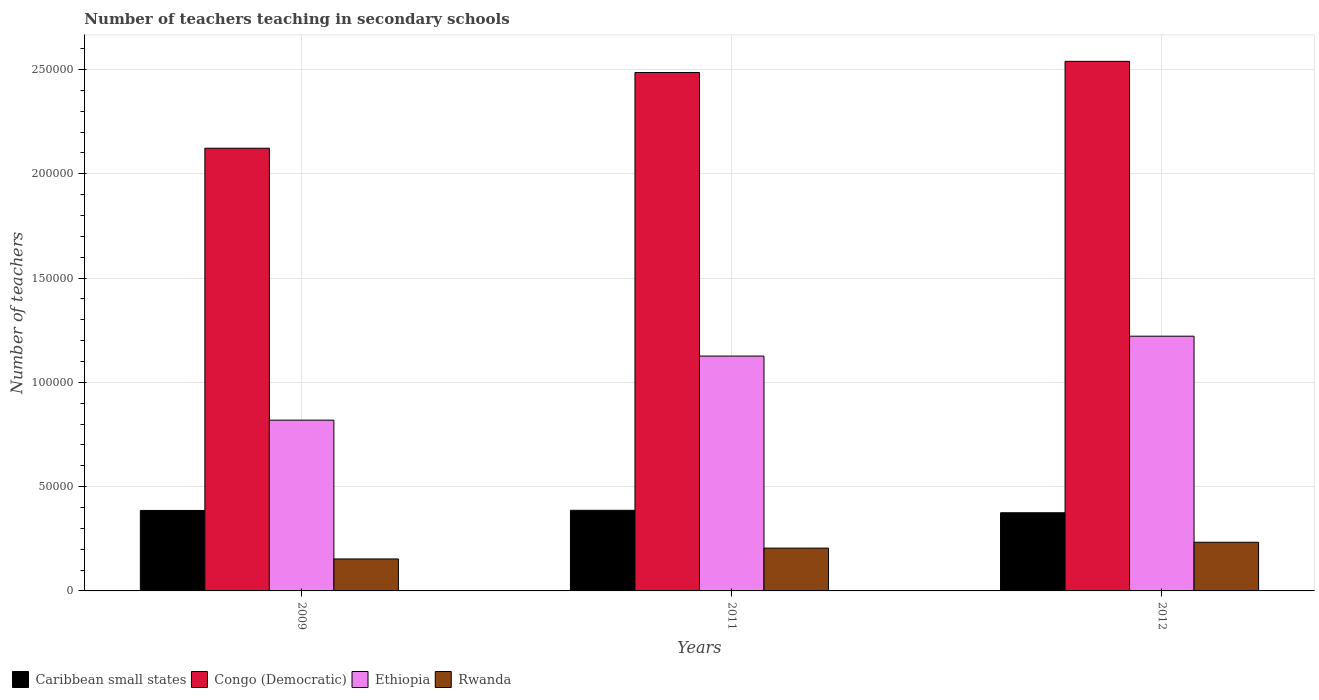How many different coloured bars are there?
Provide a succinct answer. 4. Are the number of bars per tick equal to the number of legend labels?
Make the answer very short. Yes. What is the number of teachers teaching in secondary schools in Ethiopia in 2012?
Provide a short and direct response. 1.22e+05. Across all years, what is the maximum number of teachers teaching in secondary schools in Ethiopia?
Provide a short and direct response. 1.22e+05. Across all years, what is the minimum number of teachers teaching in secondary schools in Ethiopia?
Make the answer very short. 8.19e+04. In which year was the number of teachers teaching in secondary schools in Caribbean small states minimum?
Offer a very short reply. 2012. What is the total number of teachers teaching in secondary schools in Rwanda in the graph?
Your response must be concise. 5.92e+04. What is the difference between the number of teachers teaching in secondary schools in Caribbean small states in 2011 and that in 2012?
Keep it short and to the point. 1172.01. What is the difference between the number of teachers teaching in secondary schools in Caribbean small states in 2009 and the number of teachers teaching in secondary schools in Congo (Democratic) in 2012?
Give a very brief answer. -2.15e+05. What is the average number of teachers teaching in secondary schools in Caribbean small states per year?
Offer a very short reply. 3.82e+04. In the year 2009, what is the difference between the number of teachers teaching in secondary schools in Congo (Democratic) and number of teachers teaching in secondary schools in Ethiopia?
Your answer should be very brief. 1.30e+05. What is the ratio of the number of teachers teaching in secondary schools in Rwanda in 2009 to that in 2011?
Give a very brief answer. 0.75. What is the difference between the highest and the second highest number of teachers teaching in secondary schools in Rwanda?
Give a very brief answer. 2813. What is the difference between the highest and the lowest number of teachers teaching in secondary schools in Rwanda?
Keep it short and to the point. 8006. In how many years, is the number of teachers teaching in secondary schools in Congo (Democratic) greater than the average number of teachers teaching in secondary schools in Congo (Democratic) taken over all years?
Keep it short and to the point. 2. Is the sum of the number of teachers teaching in secondary schools in Rwanda in 2009 and 2012 greater than the maximum number of teachers teaching in secondary schools in Caribbean small states across all years?
Give a very brief answer. Yes. What does the 3rd bar from the left in 2011 represents?
Offer a terse response. Ethiopia. What does the 3rd bar from the right in 2011 represents?
Provide a succinct answer. Congo (Democratic). Are all the bars in the graph horizontal?
Provide a succinct answer. No. What is the difference between two consecutive major ticks on the Y-axis?
Your answer should be very brief. 5.00e+04. Where does the legend appear in the graph?
Provide a succinct answer. Bottom left. What is the title of the graph?
Make the answer very short. Number of teachers teaching in secondary schools. What is the label or title of the Y-axis?
Your response must be concise. Number of teachers. What is the Number of teachers of Caribbean small states in 2009?
Make the answer very short. 3.86e+04. What is the Number of teachers of Congo (Democratic) in 2009?
Offer a terse response. 2.12e+05. What is the Number of teachers of Ethiopia in 2009?
Ensure brevity in your answer.  8.19e+04. What is the Number of teachers in Rwanda in 2009?
Provide a short and direct response. 1.53e+04. What is the Number of teachers in Caribbean small states in 2011?
Your answer should be very brief. 3.87e+04. What is the Number of teachers in Congo (Democratic) in 2011?
Your answer should be very brief. 2.49e+05. What is the Number of teachers in Ethiopia in 2011?
Your response must be concise. 1.13e+05. What is the Number of teachers of Rwanda in 2011?
Provide a succinct answer. 2.05e+04. What is the Number of teachers of Caribbean small states in 2012?
Provide a succinct answer. 3.75e+04. What is the Number of teachers of Congo (Democratic) in 2012?
Give a very brief answer. 2.54e+05. What is the Number of teachers in Ethiopia in 2012?
Offer a very short reply. 1.22e+05. What is the Number of teachers of Rwanda in 2012?
Offer a very short reply. 2.33e+04. Across all years, what is the maximum Number of teachers of Caribbean small states?
Ensure brevity in your answer.  3.87e+04. Across all years, what is the maximum Number of teachers in Congo (Democratic)?
Your answer should be compact. 2.54e+05. Across all years, what is the maximum Number of teachers of Ethiopia?
Provide a succinct answer. 1.22e+05. Across all years, what is the maximum Number of teachers of Rwanda?
Provide a succinct answer. 2.33e+04. Across all years, what is the minimum Number of teachers in Caribbean small states?
Your answer should be very brief. 3.75e+04. Across all years, what is the minimum Number of teachers of Congo (Democratic)?
Provide a succinct answer. 2.12e+05. Across all years, what is the minimum Number of teachers in Ethiopia?
Offer a terse response. 8.19e+04. Across all years, what is the minimum Number of teachers in Rwanda?
Provide a short and direct response. 1.53e+04. What is the total Number of teachers of Caribbean small states in the graph?
Offer a very short reply. 1.15e+05. What is the total Number of teachers in Congo (Democratic) in the graph?
Make the answer very short. 7.15e+05. What is the total Number of teachers of Ethiopia in the graph?
Offer a very short reply. 3.17e+05. What is the total Number of teachers in Rwanda in the graph?
Provide a succinct answer. 5.92e+04. What is the difference between the Number of teachers of Caribbean small states in 2009 and that in 2011?
Offer a terse response. -65.87. What is the difference between the Number of teachers in Congo (Democratic) in 2009 and that in 2011?
Make the answer very short. -3.63e+04. What is the difference between the Number of teachers in Ethiopia in 2009 and that in 2011?
Your response must be concise. -3.07e+04. What is the difference between the Number of teachers of Rwanda in 2009 and that in 2011?
Your answer should be compact. -5193. What is the difference between the Number of teachers in Caribbean small states in 2009 and that in 2012?
Ensure brevity in your answer.  1106.14. What is the difference between the Number of teachers of Congo (Democratic) in 2009 and that in 2012?
Offer a very short reply. -4.17e+04. What is the difference between the Number of teachers in Ethiopia in 2009 and that in 2012?
Your response must be concise. -4.03e+04. What is the difference between the Number of teachers of Rwanda in 2009 and that in 2012?
Your response must be concise. -8006. What is the difference between the Number of teachers in Caribbean small states in 2011 and that in 2012?
Your response must be concise. 1172.01. What is the difference between the Number of teachers of Congo (Democratic) in 2011 and that in 2012?
Your answer should be very brief. -5338. What is the difference between the Number of teachers of Ethiopia in 2011 and that in 2012?
Your answer should be compact. -9539. What is the difference between the Number of teachers of Rwanda in 2011 and that in 2012?
Ensure brevity in your answer.  -2813. What is the difference between the Number of teachers of Caribbean small states in 2009 and the Number of teachers of Congo (Democratic) in 2011?
Your answer should be very brief. -2.10e+05. What is the difference between the Number of teachers in Caribbean small states in 2009 and the Number of teachers in Ethiopia in 2011?
Offer a terse response. -7.40e+04. What is the difference between the Number of teachers in Caribbean small states in 2009 and the Number of teachers in Rwanda in 2011?
Provide a succinct answer. 1.81e+04. What is the difference between the Number of teachers of Congo (Democratic) in 2009 and the Number of teachers of Ethiopia in 2011?
Offer a terse response. 9.97e+04. What is the difference between the Number of teachers of Congo (Democratic) in 2009 and the Number of teachers of Rwanda in 2011?
Give a very brief answer. 1.92e+05. What is the difference between the Number of teachers in Ethiopia in 2009 and the Number of teachers in Rwanda in 2011?
Make the answer very short. 6.14e+04. What is the difference between the Number of teachers in Caribbean small states in 2009 and the Number of teachers in Congo (Democratic) in 2012?
Your response must be concise. -2.15e+05. What is the difference between the Number of teachers of Caribbean small states in 2009 and the Number of teachers of Ethiopia in 2012?
Offer a terse response. -8.36e+04. What is the difference between the Number of teachers in Caribbean small states in 2009 and the Number of teachers in Rwanda in 2012?
Make the answer very short. 1.53e+04. What is the difference between the Number of teachers in Congo (Democratic) in 2009 and the Number of teachers in Ethiopia in 2012?
Offer a terse response. 9.01e+04. What is the difference between the Number of teachers of Congo (Democratic) in 2009 and the Number of teachers of Rwanda in 2012?
Your response must be concise. 1.89e+05. What is the difference between the Number of teachers in Ethiopia in 2009 and the Number of teachers in Rwanda in 2012?
Provide a succinct answer. 5.86e+04. What is the difference between the Number of teachers in Caribbean small states in 2011 and the Number of teachers in Congo (Democratic) in 2012?
Provide a short and direct response. -2.15e+05. What is the difference between the Number of teachers in Caribbean small states in 2011 and the Number of teachers in Ethiopia in 2012?
Give a very brief answer. -8.35e+04. What is the difference between the Number of teachers of Caribbean small states in 2011 and the Number of teachers of Rwanda in 2012?
Give a very brief answer. 1.53e+04. What is the difference between the Number of teachers in Congo (Democratic) in 2011 and the Number of teachers in Ethiopia in 2012?
Provide a succinct answer. 1.26e+05. What is the difference between the Number of teachers in Congo (Democratic) in 2011 and the Number of teachers in Rwanda in 2012?
Make the answer very short. 2.25e+05. What is the difference between the Number of teachers in Ethiopia in 2011 and the Number of teachers in Rwanda in 2012?
Keep it short and to the point. 8.93e+04. What is the average Number of teachers in Caribbean small states per year?
Offer a very short reply. 3.82e+04. What is the average Number of teachers in Congo (Democratic) per year?
Provide a short and direct response. 2.38e+05. What is the average Number of teachers in Ethiopia per year?
Give a very brief answer. 1.06e+05. What is the average Number of teachers in Rwanda per year?
Offer a terse response. 1.97e+04. In the year 2009, what is the difference between the Number of teachers of Caribbean small states and Number of teachers of Congo (Democratic)?
Offer a terse response. -1.74e+05. In the year 2009, what is the difference between the Number of teachers in Caribbean small states and Number of teachers in Ethiopia?
Keep it short and to the point. -4.33e+04. In the year 2009, what is the difference between the Number of teachers in Caribbean small states and Number of teachers in Rwanda?
Your answer should be compact. 2.33e+04. In the year 2009, what is the difference between the Number of teachers of Congo (Democratic) and Number of teachers of Ethiopia?
Keep it short and to the point. 1.30e+05. In the year 2009, what is the difference between the Number of teachers in Congo (Democratic) and Number of teachers in Rwanda?
Offer a very short reply. 1.97e+05. In the year 2009, what is the difference between the Number of teachers in Ethiopia and Number of teachers in Rwanda?
Offer a terse response. 6.66e+04. In the year 2011, what is the difference between the Number of teachers of Caribbean small states and Number of teachers of Congo (Democratic)?
Your response must be concise. -2.10e+05. In the year 2011, what is the difference between the Number of teachers of Caribbean small states and Number of teachers of Ethiopia?
Keep it short and to the point. -7.40e+04. In the year 2011, what is the difference between the Number of teachers of Caribbean small states and Number of teachers of Rwanda?
Keep it short and to the point. 1.81e+04. In the year 2011, what is the difference between the Number of teachers in Congo (Democratic) and Number of teachers in Ethiopia?
Your response must be concise. 1.36e+05. In the year 2011, what is the difference between the Number of teachers in Congo (Democratic) and Number of teachers in Rwanda?
Provide a succinct answer. 2.28e+05. In the year 2011, what is the difference between the Number of teachers in Ethiopia and Number of teachers in Rwanda?
Your answer should be compact. 9.21e+04. In the year 2012, what is the difference between the Number of teachers of Caribbean small states and Number of teachers of Congo (Democratic)?
Your response must be concise. -2.16e+05. In the year 2012, what is the difference between the Number of teachers in Caribbean small states and Number of teachers in Ethiopia?
Give a very brief answer. -8.47e+04. In the year 2012, what is the difference between the Number of teachers in Caribbean small states and Number of teachers in Rwanda?
Offer a very short reply. 1.41e+04. In the year 2012, what is the difference between the Number of teachers in Congo (Democratic) and Number of teachers in Ethiopia?
Offer a very short reply. 1.32e+05. In the year 2012, what is the difference between the Number of teachers in Congo (Democratic) and Number of teachers in Rwanda?
Offer a terse response. 2.31e+05. In the year 2012, what is the difference between the Number of teachers in Ethiopia and Number of teachers in Rwanda?
Keep it short and to the point. 9.88e+04. What is the ratio of the Number of teachers in Caribbean small states in 2009 to that in 2011?
Your response must be concise. 1. What is the ratio of the Number of teachers of Congo (Democratic) in 2009 to that in 2011?
Provide a short and direct response. 0.85. What is the ratio of the Number of teachers in Ethiopia in 2009 to that in 2011?
Offer a terse response. 0.73. What is the ratio of the Number of teachers of Rwanda in 2009 to that in 2011?
Keep it short and to the point. 0.75. What is the ratio of the Number of teachers in Caribbean small states in 2009 to that in 2012?
Provide a short and direct response. 1.03. What is the ratio of the Number of teachers of Congo (Democratic) in 2009 to that in 2012?
Your response must be concise. 0.84. What is the ratio of the Number of teachers of Ethiopia in 2009 to that in 2012?
Keep it short and to the point. 0.67. What is the ratio of the Number of teachers in Rwanda in 2009 to that in 2012?
Offer a very short reply. 0.66. What is the ratio of the Number of teachers in Caribbean small states in 2011 to that in 2012?
Give a very brief answer. 1.03. What is the ratio of the Number of teachers in Ethiopia in 2011 to that in 2012?
Make the answer very short. 0.92. What is the ratio of the Number of teachers of Rwanda in 2011 to that in 2012?
Keep it short and to the point. 0.88. What is the difference between the highest and the second highest Number of teachers in Caribbean small states?
Provide a short and direct response. 65.87. What is the difference between the highest and the second highest Number of teachers in Congo (Democratic)?
Ensure brevity in your answer.  5338. What is the difference between the highest and the second highest Number of teachers of Ethiopia?
Your answer should be very brief. 9539. What is the difference between the highest and the second highest Number of teachers of Rwanda?
Ensure brevity in your answer.  2813. What is the difference between the highest and the lowest Number of teachers of Caribbean small states?
Your answer should be very brief. 1172.01. What is the difference between the highest and the lowest Number of teachers in Congo (Democratic)?
Offer a very short reply. 4.17e+04. What is the difference between the highest and the lowest Number of teachers in Ethiopia?
Your response must be concise. 4.03e+04. What is the difference between the highest and the lowest Number of teachers of Rwanda?
Your response must be concise. 8006. 